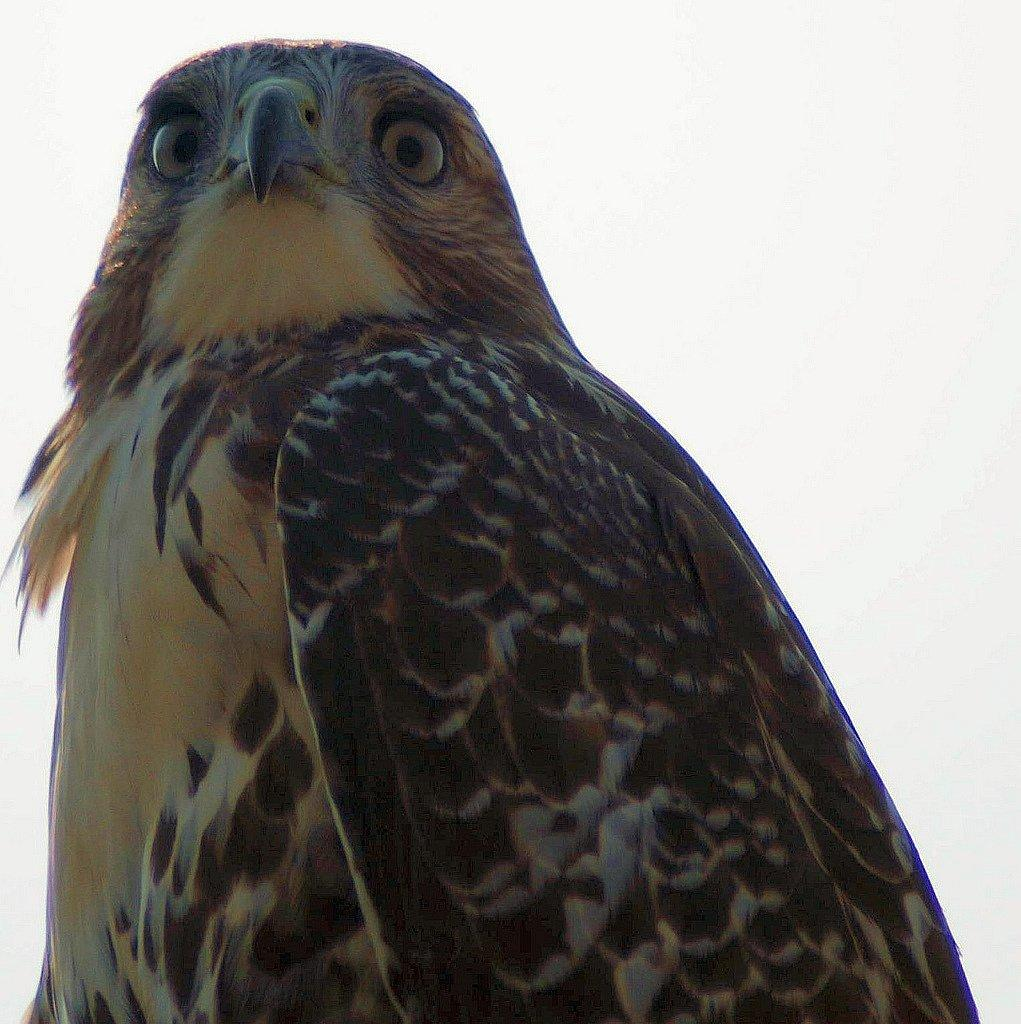What animal is the main subject of the image? There is an eagle in the image. What color is the background of the image? The background of the image is white. What is the name of the protest happening in the background of the image? There is no protest present in the image; the background is white. How many dimes can be seen on the eagle's wings in the image? There are no dimes present in the image; it features an eagle and a white background. 